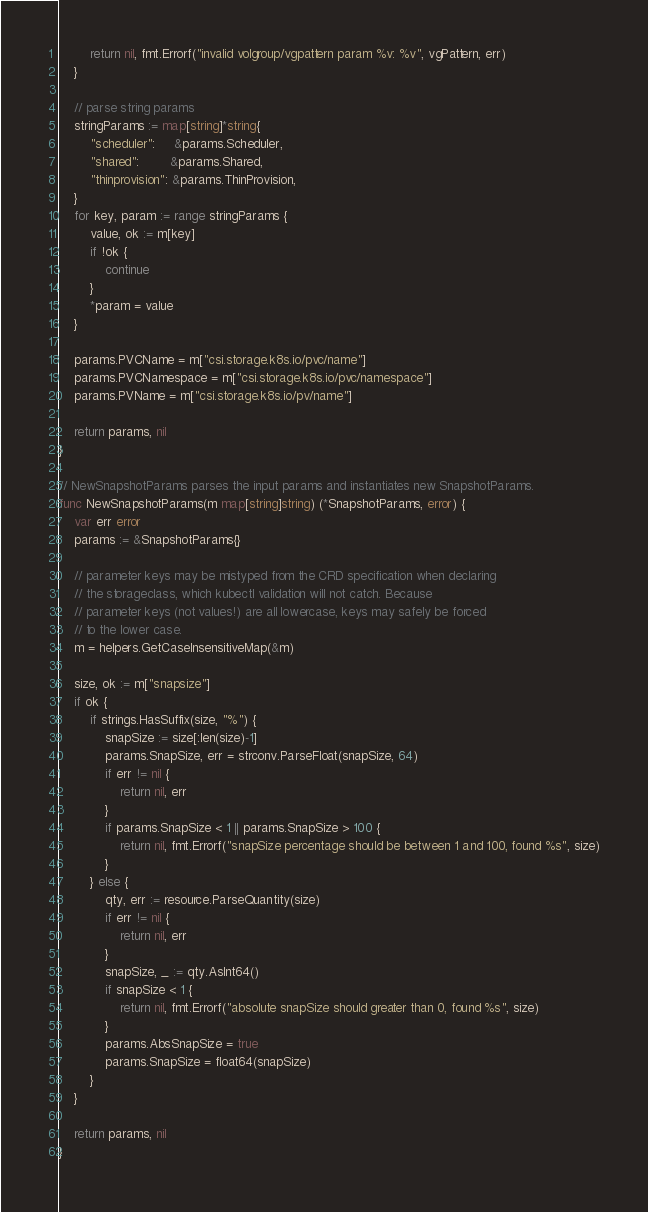Convert code to text. <code><loc_0><loc_0><loc_500><loc_500><_Go_>		return nil, fmt.Errorf("invalid volgroup/vgpattern param %v: %v", vgPattern, err)
	}

	// parse string params
	stringParams := map[string]*string{
		"scheduler":     &params.Scheduler,
		"shared":        &params.Shared,
		"thinprovision": &params.ThinProvision,
	}
	for key, param := range stringParams {
		value, ok := m[key]
		if !ok {
			continue
		}
		*param = value
	}

	params.PVCName = m["csi.storage.k8s.io/pvc/name"]
	params.PVCNamespace = m["csi.storage.k8s.io/pvc/namespace"]
	params.PVName = m["csi.storage.k8s.io/pv/name"]

	return params, nil
}

// NewSnapshotParams parses the input params and instantiates new SnapshotParams.
func NewSnapshotParams(m map[string]string) (*SnapshotParams, error) {
	var err error
	params := &SnapshotParams{}

	// parameter keys may be mistyped from the CRD specification when declaring
	// the storageclass, which kubectl validation will not catch. Because
	// parameter keys (not values!) are all lowercase, keys may safely be forced
	// to the lower case.
	m = helpers.GetCaseInsensitiveMap(&m)

	size, ok := m["snapsize"]
	if ok {
		if strings.HasSuffix(size, "%") {
			snapSize := size[:len(size)-1]
			params.SnapSize, err = strconv.ParseFloat(snapSize, 64)
			if err != nil {
				return nil, err
			}
			if params.SnapSize < 1 || params.SnapSize > 100 {
				return nil, fmt.Errorf("snapSize percentage should be between 1 and 100, found %s", size)
			}
		} else {
			qty, err := resource.ParseQuantity(size)
			if err != nil {
				return nil, err
			}
			snapSize, _ := qty.AsInt64()
			if snapSize < 1 {
				return nil, fmt.Errorf("absolute snapSize should greater than 0, found %s", size)
			}
			params.AbsSnapSize = true
			params.SnapSize = float64(snapSize)
		}
	}

	return params, nil
}
</code> 